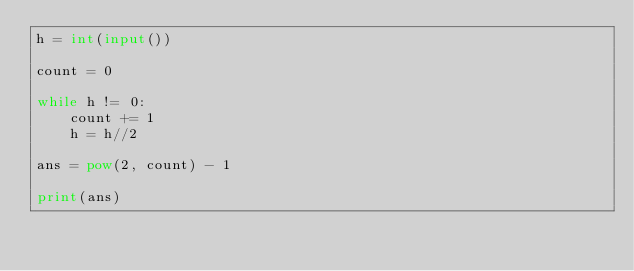Convert code to text. <code><loc_0><loc_0><loc_500><loc_500><_Python_>h = int(input())

count = 0

while h != 0:
    count += 1
    h = h//2

ans = pow(2, count) - 1

print(ans)</code> 